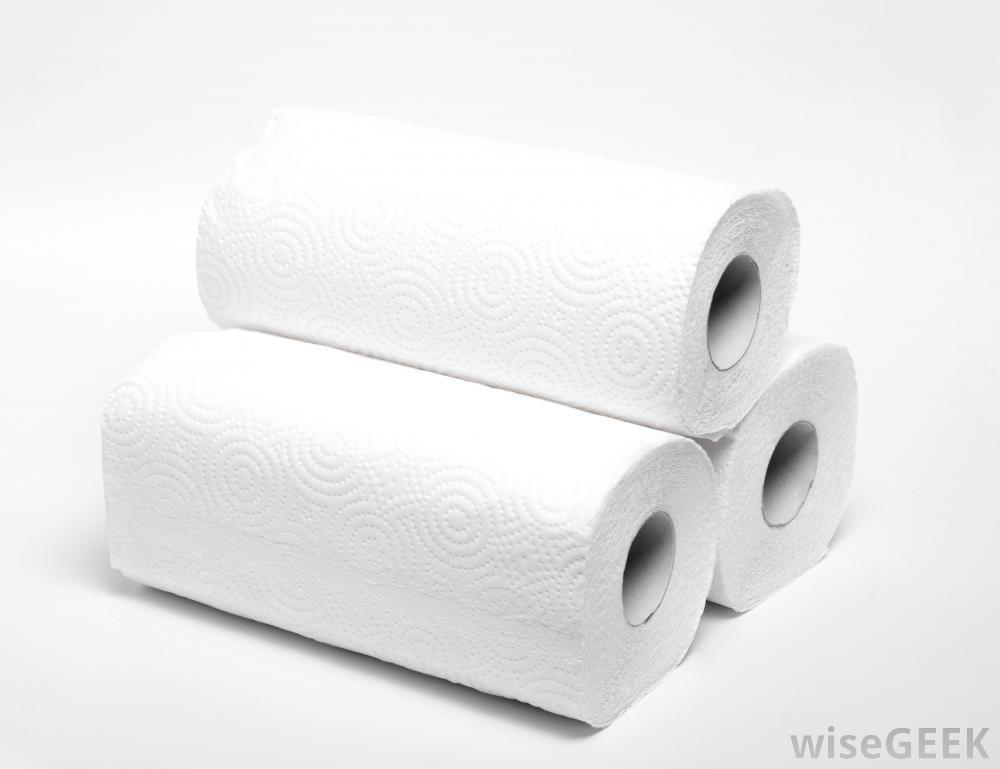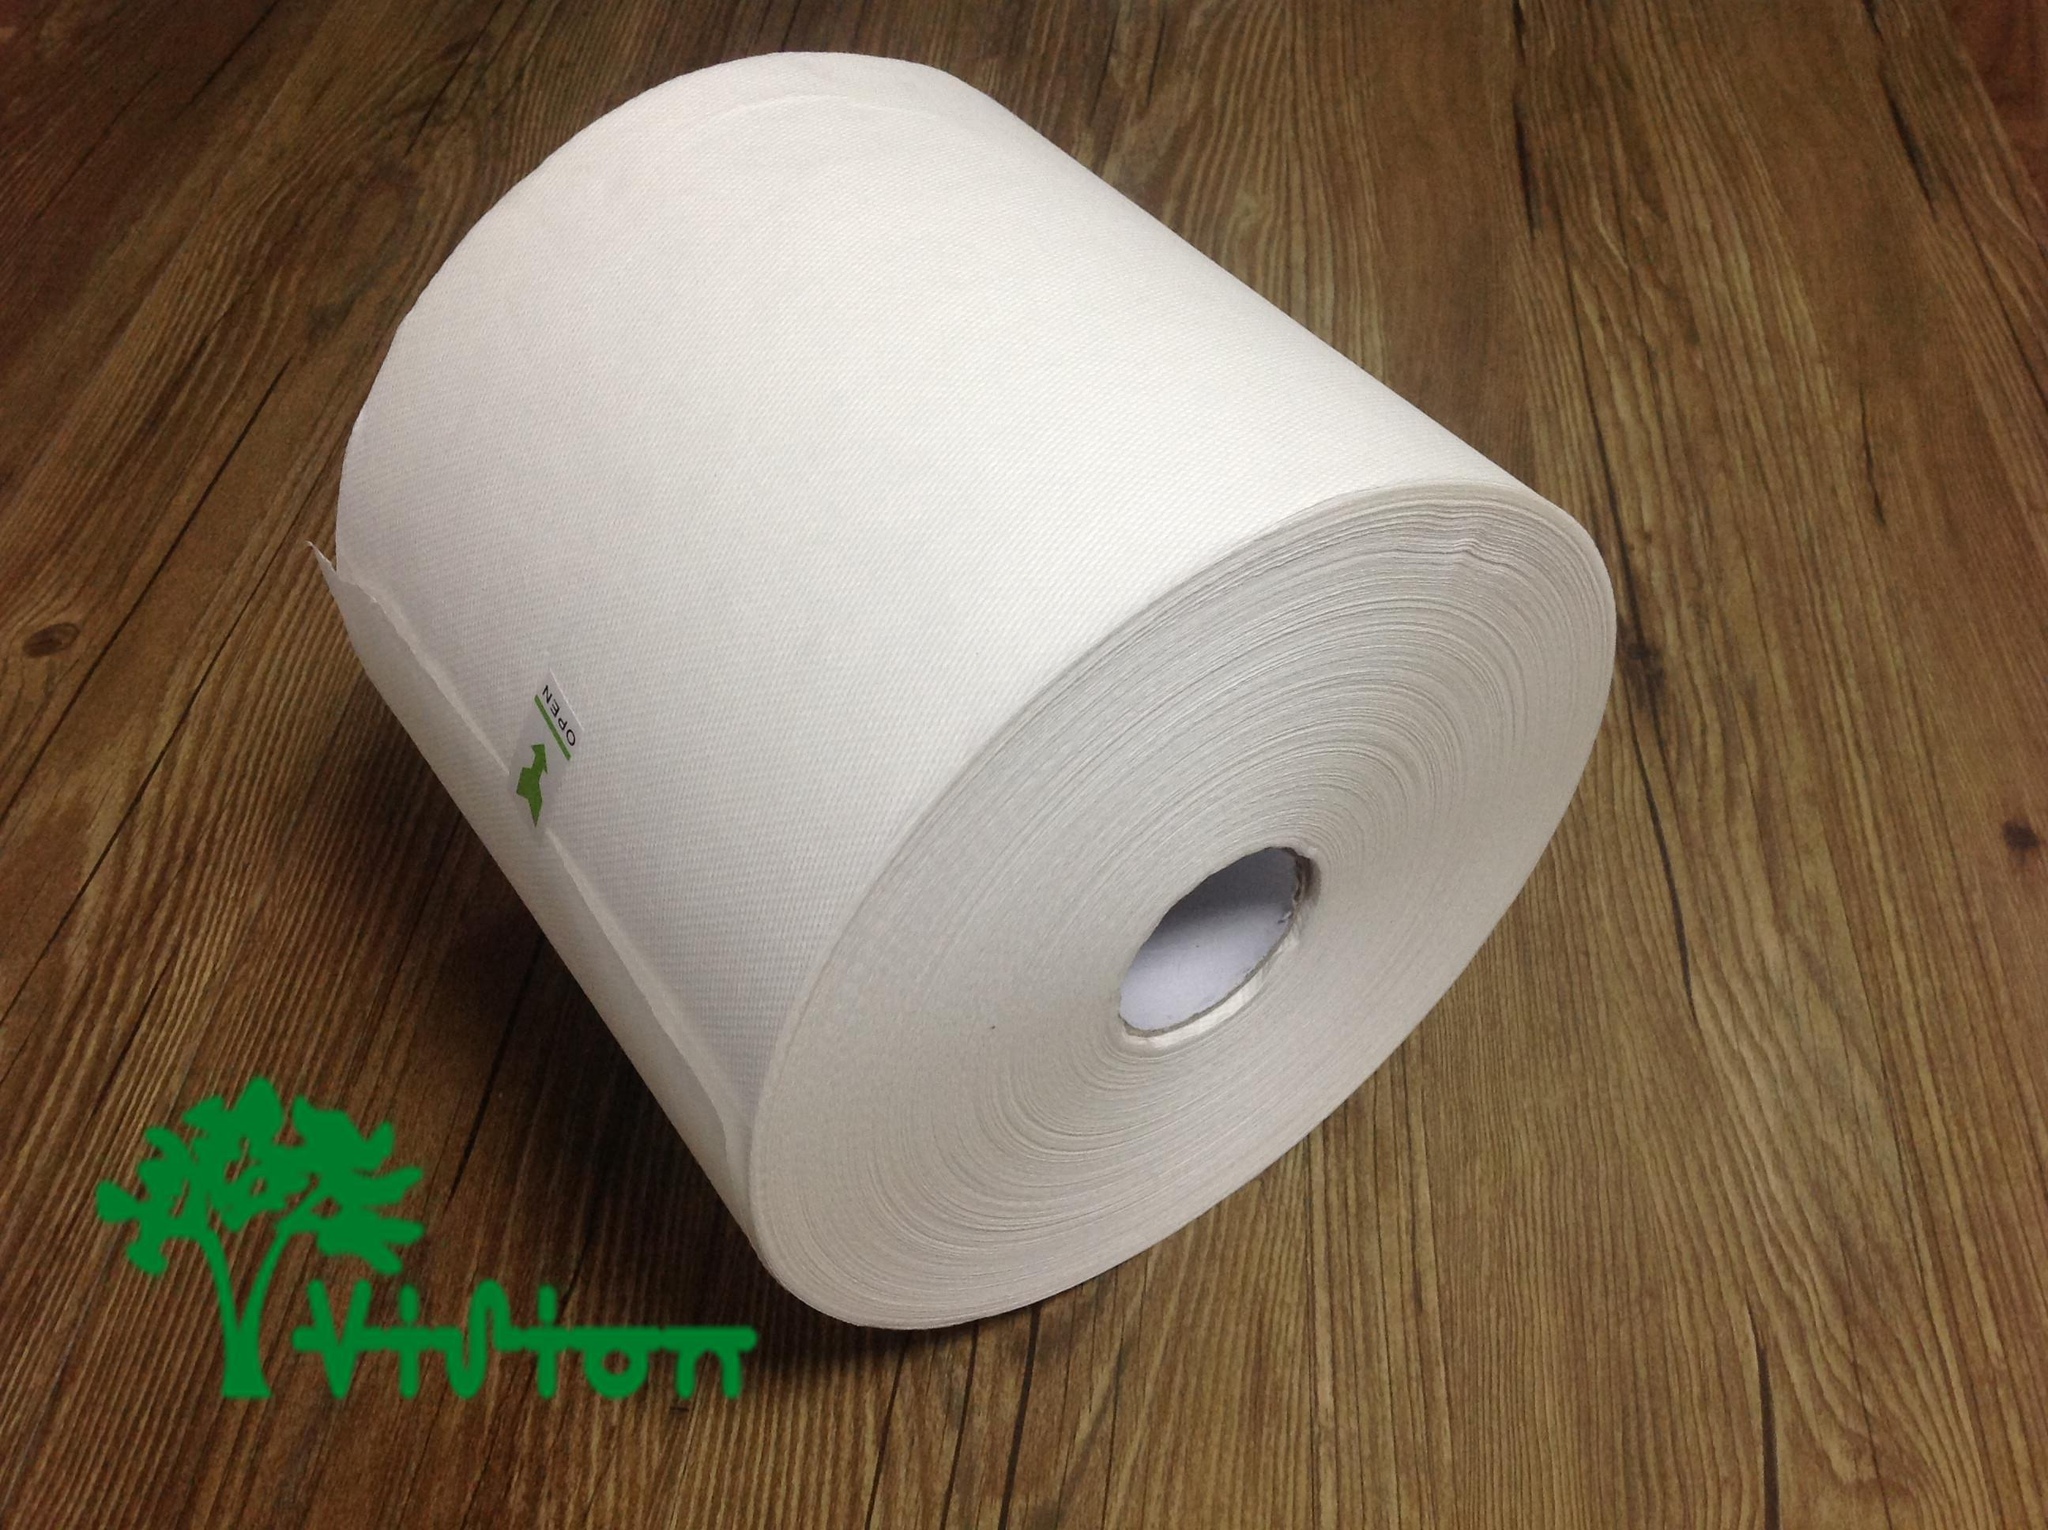The first image is the image on the left, the second image is the image on the right. Examine the images to the left and right. Is the description "An image shows a single white roll on a wood surface." accurate? Answer yes or no. Yes. 